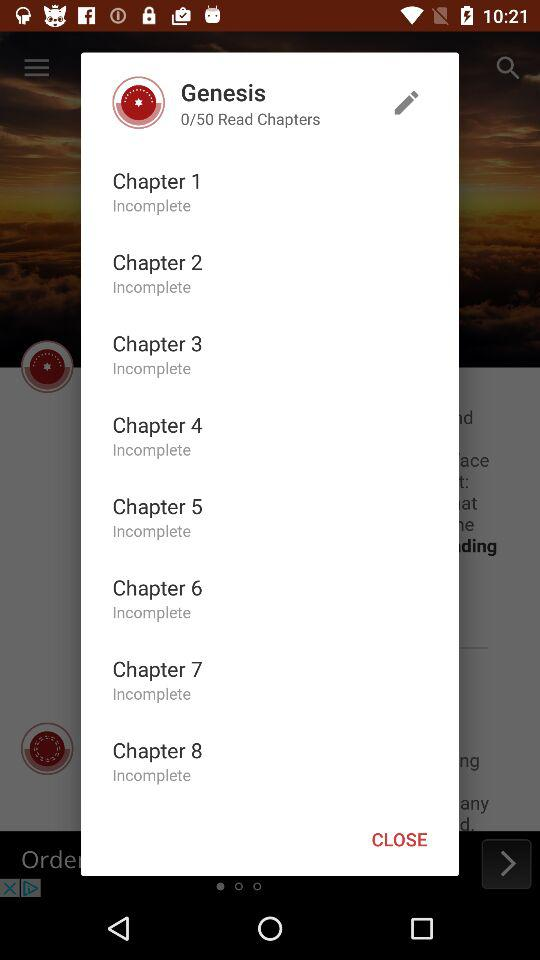How many chapters have been completed?
When the provided information is insufficient, respond with <no answer>. <no answer> 